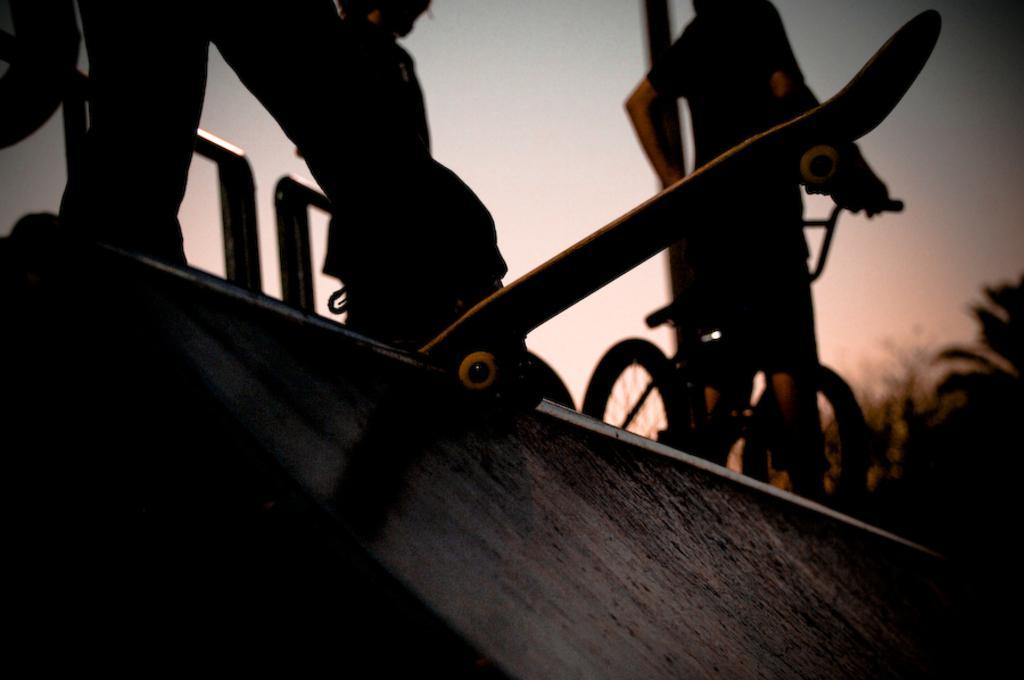How would you summarize this image in a sentence or two? A human is standing on a skateboard. In the right side a person is standing with a cycle. 